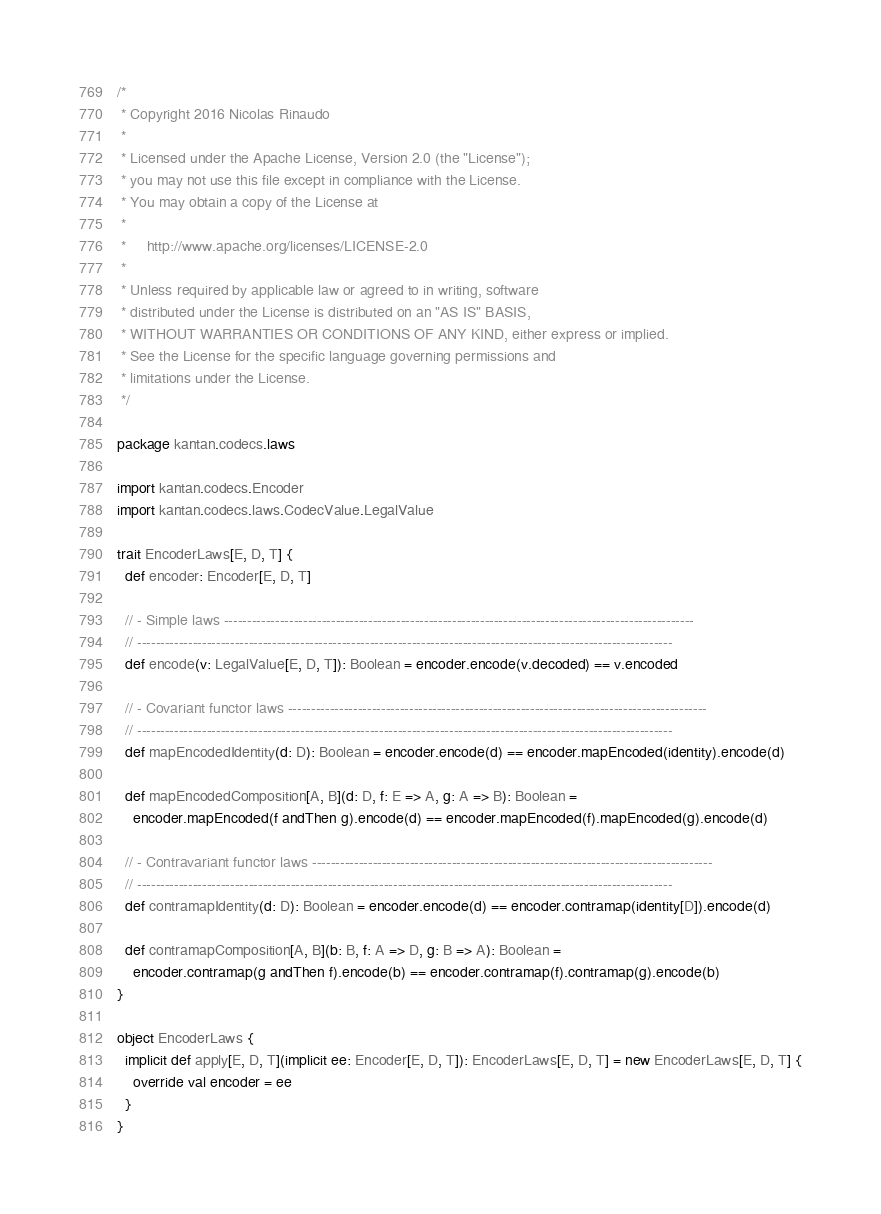Convert code to text. <code><loc_0><loc_0><loc_500><loc_500><_Scala_>/*
 * Copyright 2016 Nicolas Rinaudo
 *
 * Licensed under the Apache License, Version 2.0 (the "License");
 * you may not use this file except in compliance with the License.
 * You may obtain a copy of the License at
 *
 *     http://www.apache.org/licenses/LICENSE-2.0
 *
 * Unless required by applicable law or agreed to in writing, software
 * distributed under the License is distributed on an "AS IS" BASIS,
 * WITHOUT WARRANTIES OR CONDITIONS OF ANY KIND, either express or implied.
 * See the License for the specific language governing permissions and
 * limitations under the License.
 */

package kantan.codecs.laws

import kantan.codecs.Encoder
import kantan.codecs.laws.CodecValue.LegalValue

trait EncoderLaws[E, D, T] {
  def encoder: Encoder[E, D, T]

  // - Simple laws -----------------------------------------------------------------------------------------------------
  // -------------------------------------------------------------------------------------------------------------------
  def encode(v: LegalValue[E, D, T]): Boolean = encoder.encode(v.decoded) == v.encoded

  // - Covariant functor laws ------------------------------------------------------------------------------------------
  // -------------------------------------------------------------------------------------------------------------------
  def mapEncodedIdentity(d: D): Boolean = encoder.encode(d) == encoder.mapEncoded(identity).encode(d)

  def mapEncodedComposition[A, B](d: D, f: E => A, g: A => B): Boolean =
    encoder.mapEncoded(f andThen g).encode(d) == encoder.mapEncoded(f).mapEncoded(g).encode(d)

  // - Contravariant functor laws --------------------------------------------------------------------------------------
  // -------------------------------------------------------------------------------------------------------------------
  def contramapIdentity(d: D): Boolean = encoder.encode(d) == encoder.contramap(identity[D]).encode(d)

  def contramapComposition[A, B](b: B, f: A => D, g: B => A): Boolean =
    encoder.contramap(g andThen f).encode(b) == encoder.contramap(f).contramap(g).encode(b)
}

object EncoderLaws {
  implicit def apply[E, D, T](implicit ee: Encoder[E, D, T]): EncoderLaws[E, D, T] = new EncoderLaws[E, D, T] {
    override val encoder = ee
  }
}
</code> 